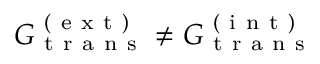<formula> <loc_0><loc_0><loc_500><loc_500>G _ { t r a n s } ^ { ( e x t ) } \neq G _ { t r a n s } ^ { ( i n t ) }</formula> 